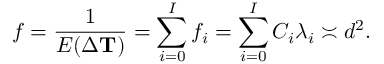Convert formula to latex. <formula><loc_0><loc_0><loc_500><loc_500>f = \frac { 1 } { E ( \Delta T ) } = \sum _ { i = 0 } ^ { I } f _ { i } = \sum _ { i = 0 } ^ { I } C _ { i } \lambda _ { i } \asymp d ^ { 2 } .</formula> 